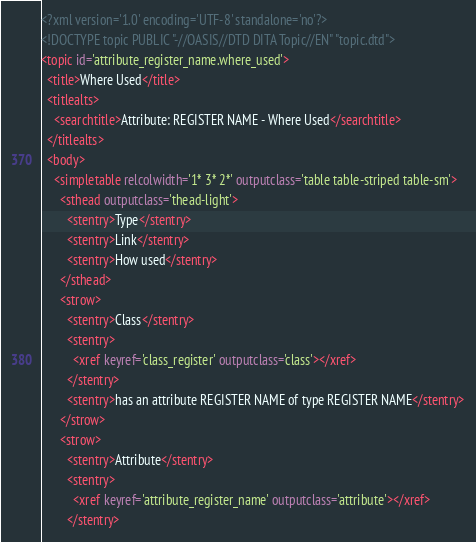Convert code to text. <code><loc_0><loc_0><loc_500><loc_500><_XML_><?xml version='1.0' encoding='UTF-8' standalone='no'?>
<!DOCTYPE topic PUBLIC "-//OASIS//DTD DITA Topic//EN" "topic.dtd">
<topic id='attribute_register_name.where_used'>
  <title>Where Used</title>
  <titlealts>
    <searchtitle>Attribute: REGISTER NAME - Where Used</searchtitle>
  </titlealts>
  <body>
    <simpletable relcolwidth='1* 3* 2*' outputclass='table table-striped table-sm'>
      <sthead outputclass='thead-light'>
        <stentry>Type</stentry>
        <stentry>Link</stentry>
        <stentry>How used</stentry>
      </sthead>
      <strow>
        <stentry>Class</stentry>
        <stentry>
          <xref keyref='class_register' outputclass='class'></xref>
        </stentry>
        <stentry>has an attribute REGISTER NAME of type REGISTER NAME</stentry>
      </strow>
      <strow>
        <stentry>Attribute</stentry>
        <stentry>
          <xref keyref='attribute_register_name' outputclass='attribute'></xref>
        </stentry></code> 